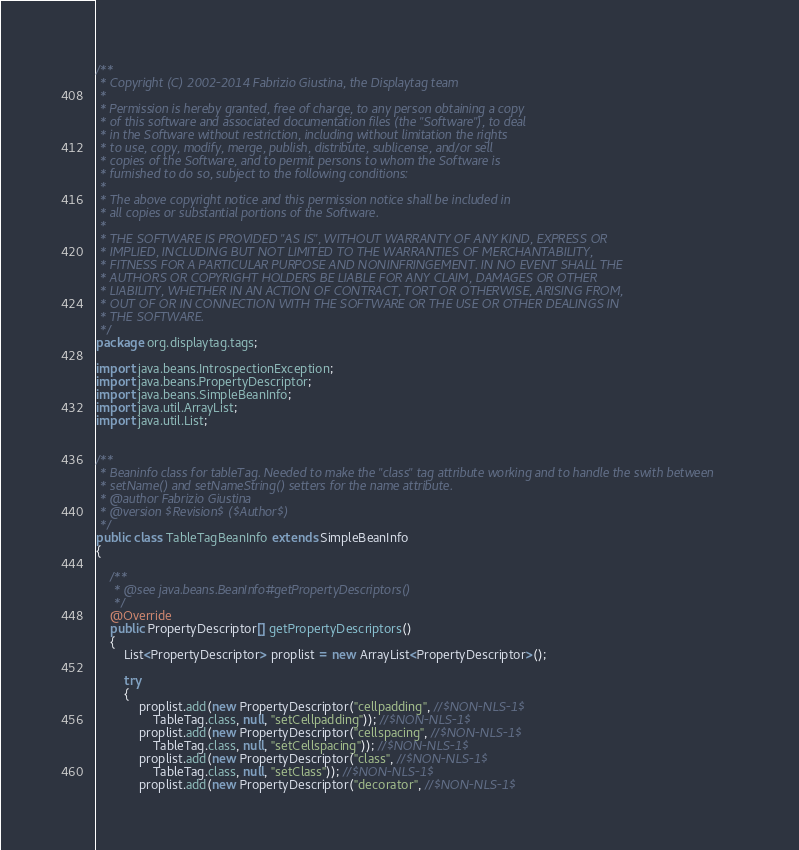<code> <loc_0><loc_0><loc_500><loc_500><_Java_>/**
 * Copyright (C) 2002-2014 Fabrizio Giustina, the Displaytag team
 *
 * Permission is hereby granted, free of charge, to any person obtaining a copy
 * of this software and associated documentation files (the "Software"), to deal
 * in the Software without restriction, including without limitation the rights
 * to use, copy, modify, merge, publish, distribute, sublicense, and/or sell
 * copies of the Software, and to permit persons to whom the Software is
 * furnished to do so, subject to the following conditions:
 *
 * The above copyright notice and this permission notice shall be included in
 * all copies or substantial portions of the Software.
 *
 * THE SOFTWARE IS PROVIDED "AS IS", WITHOUT WARRANTY OF ANY KIND, EXPRESS OR
 * IMPLIED, INCLUDING BUT NOT LIMITED TO THE WARRANTIES OF MERCHANTABILITY,
 * FITNESS FOR A PARTICULAR PURPOSE AND NONINFRINGEMENT. IN NO EVENT SHALL THE
 * AUTHORS OR COPYRIGHT HOLDERS BE LIABLE FOR ANY CLAIM, DAMAGES OR OTHER
 * LIABILITY, WHETHER IN AN ACTION OF CONTRACT, TORT OR OTHERWISE, ARISING FROM,
 * OUT OF OR IN CONNECTION WITH THE SOFTWARE OR THE USE OR OTHER DEALINGS IN
 * THE SOFTWARE.
 */
package org.displaytag.tags;

import java.beans.IntrospectionException;
import java.beans.PropertyDescriptor;
import java.beans.SimpleBeanInfo;
import java.util.ArrayList;
import java.util.List;


/**
 * Beaninfo class for tableTag. Needed to make the "class" tag attribute working and to handle the swith between
 * setName() and setNameString() setters for the name attribute.
 * @author Fabrizio Giustina
 * @version $Revision$ ($Author$)
 */
public class TableTagBeanInfo extends SimpleBeanInfo
{

    /**
     * @see java.beans.BeanInfo#getPropertyDescriptors()
     */
    @Override
    public PropertyDescriptor[] getPropertyDescriptors()
    {
        List<PropertyDescriptor> proplist = new ArrayList<PropertyDescriptor>();

        try
        {
            proplist.add(new PropertyDescriptor("cellpadding", //$NON-NLS-1$
                TableTag.class, null, "setCellpadding")); //$NON-NLS-1$
            proplist.add(new PropertyDescriptor("cellspacing", //$NON-NLS-1$
                TableTag.class, null, "setCellspacing")); //$NON-NLS-1$
            proplist.add(new PropertyDescriptor("class", //$NON-NLS-1$
                TableTag.class, null, "setClass")); //$NON-NLS-1$
            proplist.add(new PropertyDescriptor("decorator", //$NON-NLS-1$</code> 